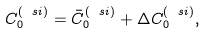<formula> <loc_0><loc_0><loc_500><loc_500>C _ { 0 } ^ { ( \ s i ) } = \bar { C } _ { 0 } ^ { ( \ s i ) } + \Delta C _ { 0 } ^ { ( \ s i ) } ,</formula> 